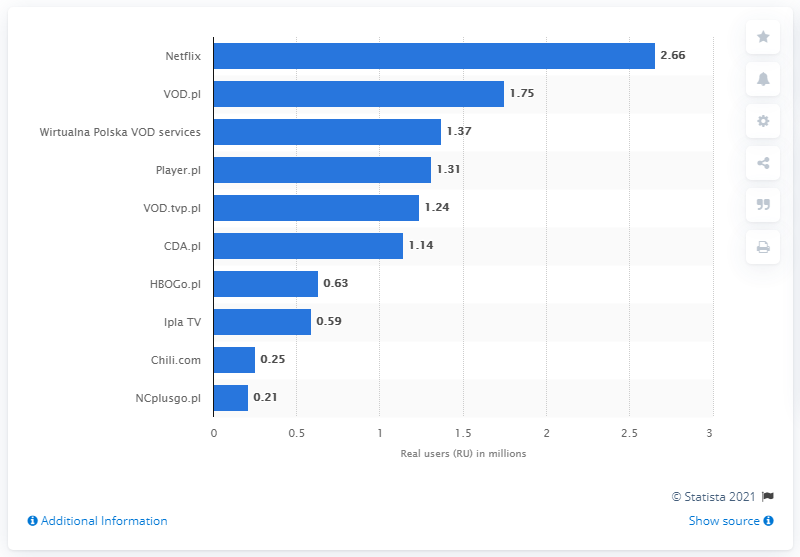Specify some key components in this picture. It is clear that Netflix has the highest value among the three options presented. The sum of real users who are below 1 million is 1.68 million. 